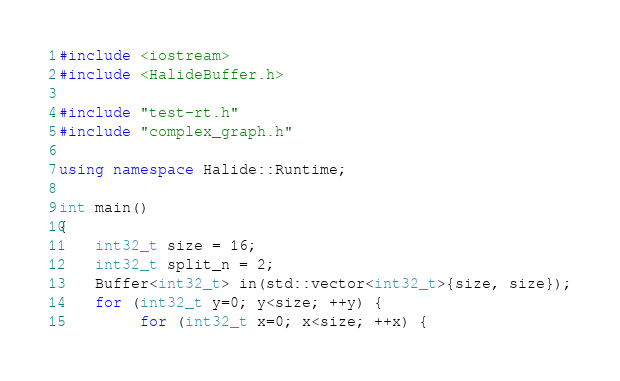<code> <loc_0><loc_0><loc_500><loc_500><_C++_>#include <iostream>
#include <HalideBuffer.h>

#include "test-rt.h"
#include "complex_graph.h"

using namespace Halide::Runtime;

int main()
{
    int32_t size = 16;
    int32_t split_n = 2;
    Buffer<int32_t> in(std::vector<int32_t>{size, size});
    for (int32_t y=0; y<size; ++y) {
         for (int32_t x=0; x<size; ++x) {</code> 